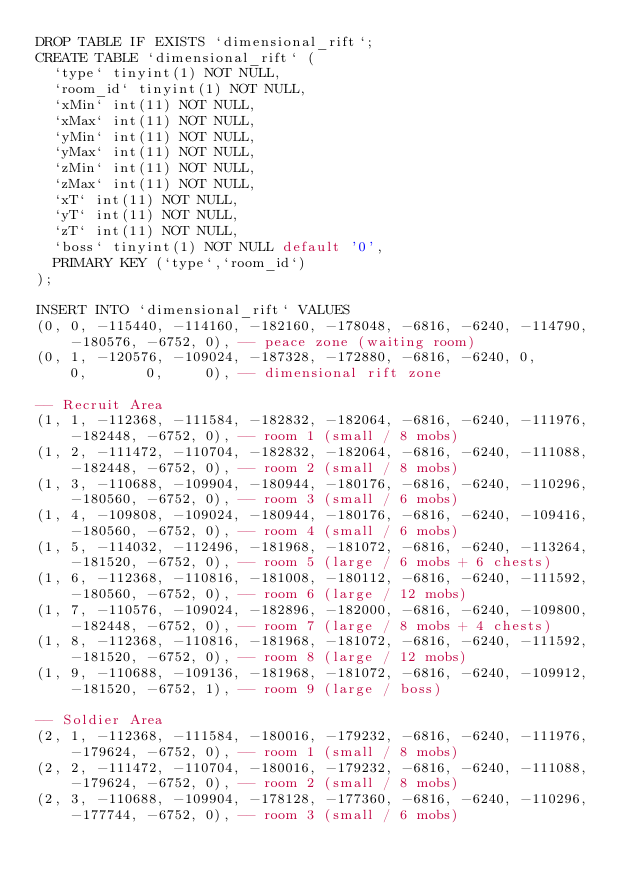<code> <loc_0><loc_0><loc_500><loc_500><_SQL_>DROP TABLE IF EXISTS `dimensional_rift`;
CREATE TABLE `dimensional_rift` (
  `type` tinyint(1) NOT NULL,
  `room_id` tinyint(1) NOT NULL,
  `xMin` int(11) NOT NULL,
  `xMax` int(11) NOT NULL,
  `yMin` int(11) NOT NULL,
  `yMax` int(11) NOT NULL,
  `zMin` int(11) NOT NULL,
  `zMax` int(11) NOT NULL,
  `xT` int(11) NOT NULL,
  `yT` int(11) NOT NULL,
  `zT` int(11) NOT NULL,
  `boss` tinyint(1) NOT NULL default '0',
  PRIMARY KEY (`type`,`room_id`)
);

INSERT INTO `dimensional_rift` VALUES
(0, 0, -115440, -114160, -182160, -178048, -6816, -6240, -114790, -180576, -6752, 0),	-- peace zone (waiting room)
(0, 1, -120576, -109024, -187328, -172880, -6816, -6240, 0,       0,       0,     0),	-- dimensional rift zone

-- Recruit Area
(1, 1, -112368, -111584, -182832, -182064, -6816, -6240, -111976, -182448, -6752, 0),	-- room 1 (small / 8 mobs)
(1, 2, -111472, -110704, -182832, -182064, -6816, -6240, -111088, -182448, -6752, 0),	-- room 2 (small / 8 mobs)
(1, 3, -110688, -109904, -180944, -180176, -6816, -6240, -110296, -180560, -6752, 0),	-- room 3 (small / 6 mobs)
(1, 4, -109808, -109024, -180944, -180176, -6816, -6240, -109416, -180560, -6752, 0),	-- room 4 (small / 6 mobs)
(1, 5, -114032, -112496, -181968, -181072, -6816, -6240, -113264, -181520, -6752, 0),	-- room 5 (large / 6 mobs + 6 chests)
(1, 6, -112368, -110816, -181008, -180112, -6816, -6240, -111592, -180560, -6752, 0),	-- room 6 (large / 12 mobs)
(1, 7, -110576, -109024, -182896, -182000, -6816, -6240, -109800, -182448, -6752, 0),	-- room 7 (large / 8 mobs + 4 chests)
(1, 8, -112368, -110816, -181968, -181072, -6816, -6240, -111592, -181520, -6752, 0),	-- room 8 (large / 12 mobs)
(1, 9, -110688, -109136, -181968, -181072, -6816, -6240, -109912, -181520, -6752, 1),	-- room 9 (large / boss)

-- Soldier Area
(2, 1, -112368, -111584, -180016, -179232, -6816, -6240, -111976, -179624, -6752, 0),	-- room 1 (small / 8 mobs)
(2, 2, -111472, -110704, -180016, -179232, -6816, -6240, -111088, -179624, -6752, 0),	-- room 2 (small / 8 mobs)
(2, 3, -110688, -109904, -178128, -177360, -6816, -6240, -110296, -177744, -6752, 0),	-- room 3 (small / 6 mobs)</code> 